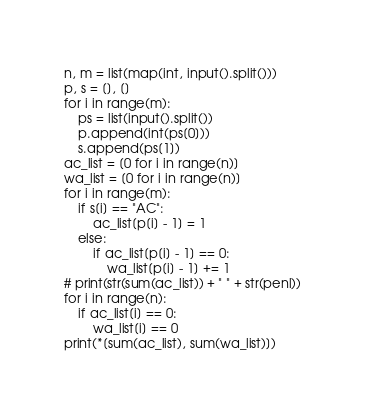<code> <loc_0><loc_0><loc_500><loc_500><_Python_>n, m = list(map(int, input().split()))
p, s = [], []
for i in range(m):
    ps = list(input().split())
    p.append(int(ps[0]))
    s.append(ps[1])
ac_list = [0 for i in range(n)]
wa_list = [0 for i in range(n)]
for i in range(m):
    if s[i] == "AC":
        ac_list[p[i] - 1] = 1
    else:
        if ac_list[p[i] - 1] == 0:
            wa_list[p[i] - 1] += 1
# print(str(sum(ac_list)) + " " + str(penl))
for i in range(n):
    if ac_list[i] == 0:
        wa_list[i] == 0
print(*[sum(ac_list), sum(wa_list)])
</code> 